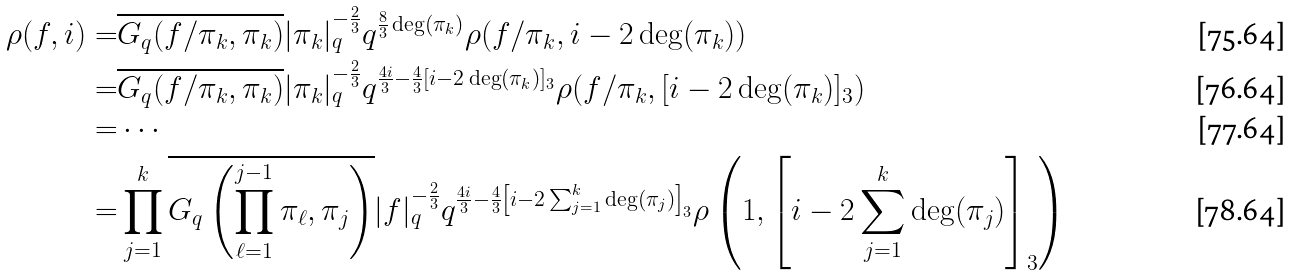<formula> <loc_0><loc_0><loc_500><loc_500>\rho ( f , i ) = & \overline { G _ { q } ( f / \pi _ { k } , \pi _ { k } ) } | \pi _ { k } | _ { q } ^ { - \frac { 2 } { 3 } } q ^ { \frac { 8 } { 3 } \deg ( \pi _ { k } ) } \rho ( f / \pi _ { k } , i - 2 \deg ( \pi _ { k } ) ) \\ = & \overline { G _ { q } ( f / \pi _ { k } , \pi _ { k } ) } | \pi _ { k } | _ { q } ^ { - \frac { 2 } { 3 } } q ^ { \frac { 4 i } { 3 } - \frac { 4 } { 3 } [ i - 2 \deg ( \pi _ { k } ) ] _ { 3 } } \rho ( f / \pi _ { k } , [ i - 2 \deg ( \pi _ { k } ) ] _ { 3 } ) \\ = & \cdots \\ = & \prod _ { j = 1 } ^ { k } \overline { G _ { q } \left ( \prod _ { \ell = 1 } ^ { j - 1 } \pi _ { \ell } , \pi _ { j } \right ) } | f | _ { q } ^ { - \frac { 2 } { 3 } } q ^ { \frac { 4 i } { 3 } - \frac { 4 } { 3 } \left [ i - 2 \sum _ { j = 1 } ^ { k } \deg ( \pi _ { j } ) \right ] _ { 3 } } \rho \left ( 1 , \left [ i - 2 \sum _ { j = 1 } ^ { k } \deg ( \pi _ { j } ) \right ] _ { 3 } \right )</formula> 